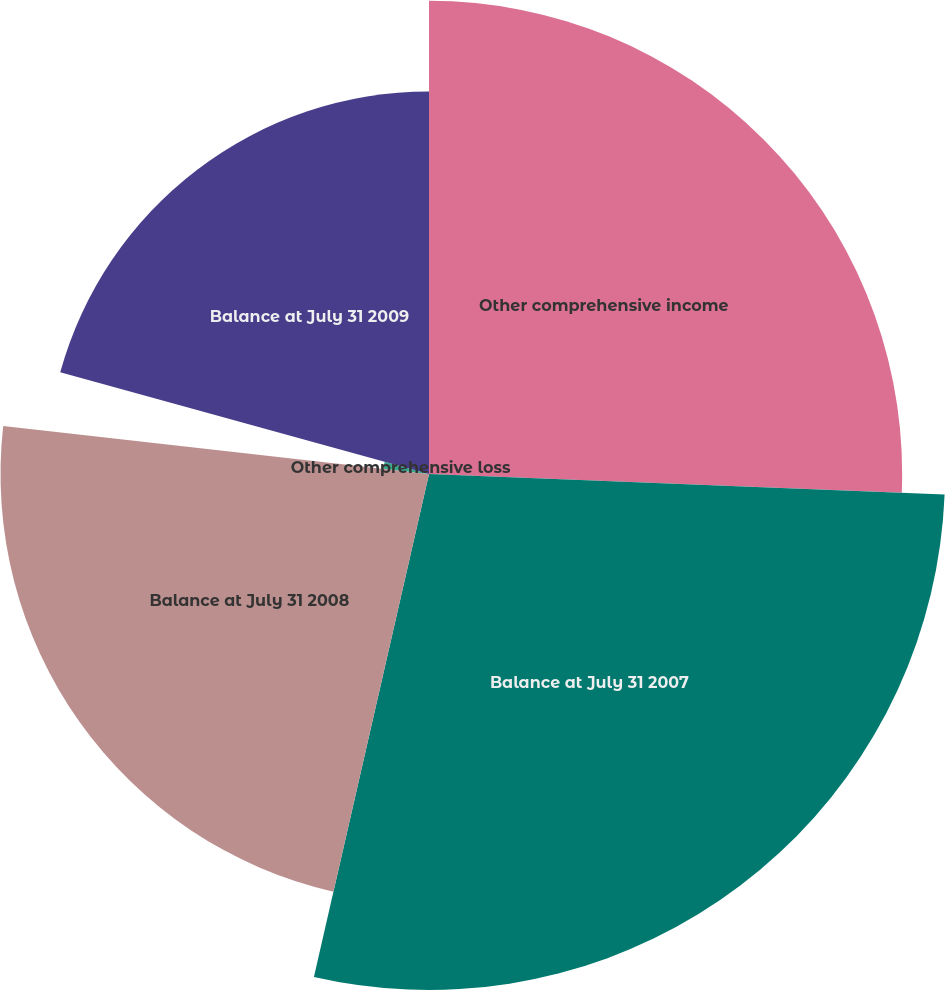<chart> <loc_0><loc_0><loc_500><loc_500><pie_chart><fcel>Other comprehensive income<fcel>Balance at July 31 2007<fcel>Balance at July 31 2008<fcel>Other comprehensive loss<fcel>Balance at July 31 2009<nl><fcel>25.63%<fcel>27.95%<fcel>23.21%<fcel>2.49%<fcel>20.72%<nl></chart> 